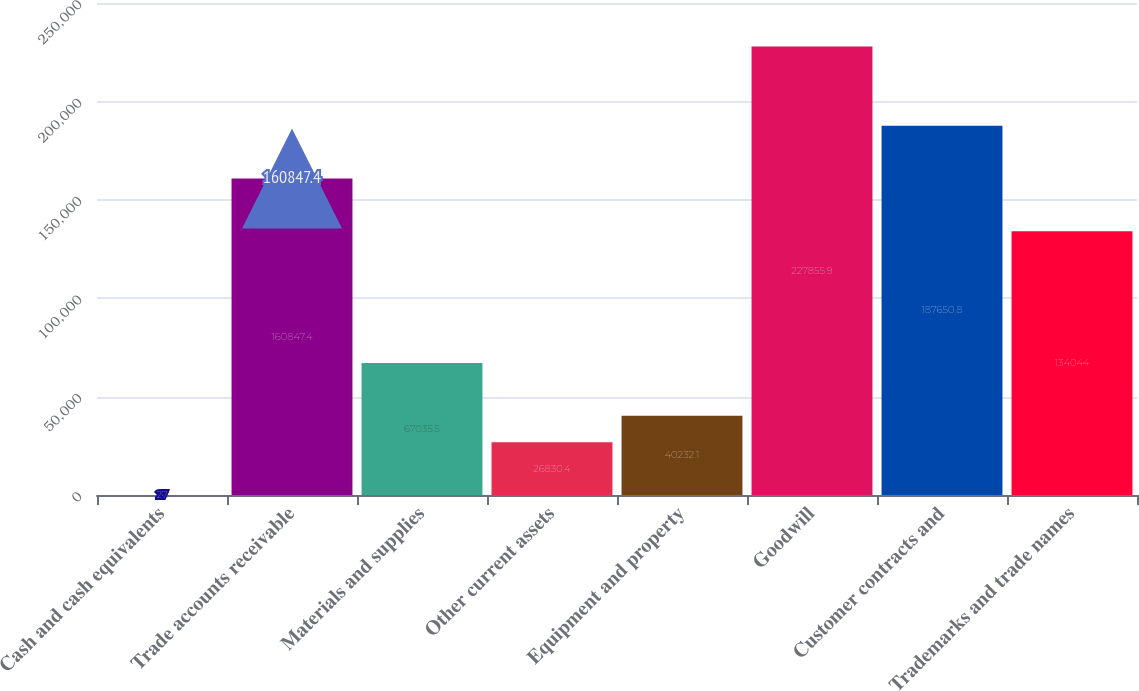<chart> <loc_0><loc_0><loc_500><loc_500><bar_chart><fcel>Cash and cash equivalents<fcel>Trade accounts receivable<fcel>Materials and supplies<fcel>Other current assets<fcel>Equipment and property<fcel>Goodwill<fcel>Customer contracts and<fcel>Trademarks and trade names<nl><fcel>27<fcel>160847<fcel>67035.5<fcel>26830.4<fcel>40232.1<fcel>227856<fcel>187651<fcel>134044<nl></chart> 